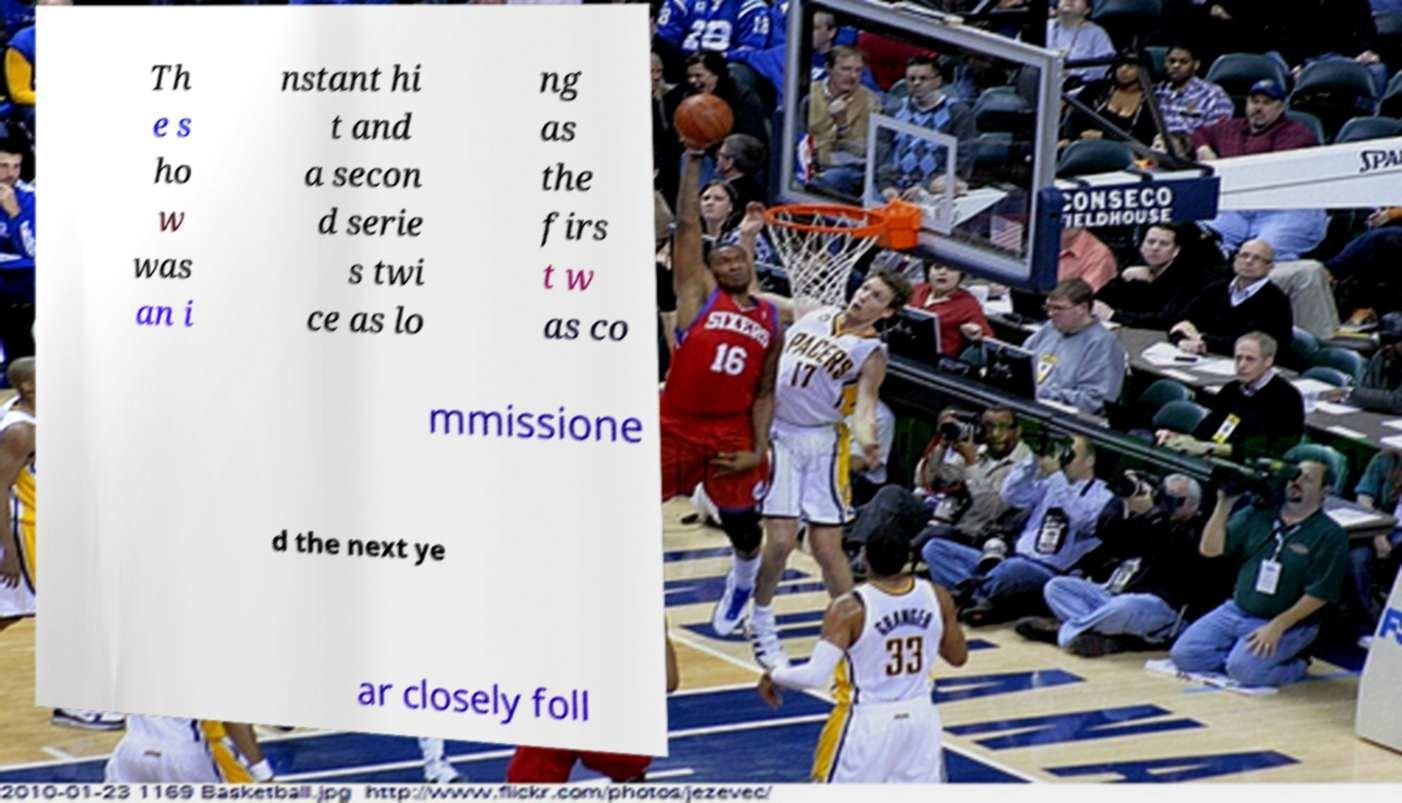Could you extract and type out the text from this image? Th e s ho w was an i nstant hi t and a secon d serie s twi ce as lo ng as the firs t w as co mmissione d the next ye ar closely foll 